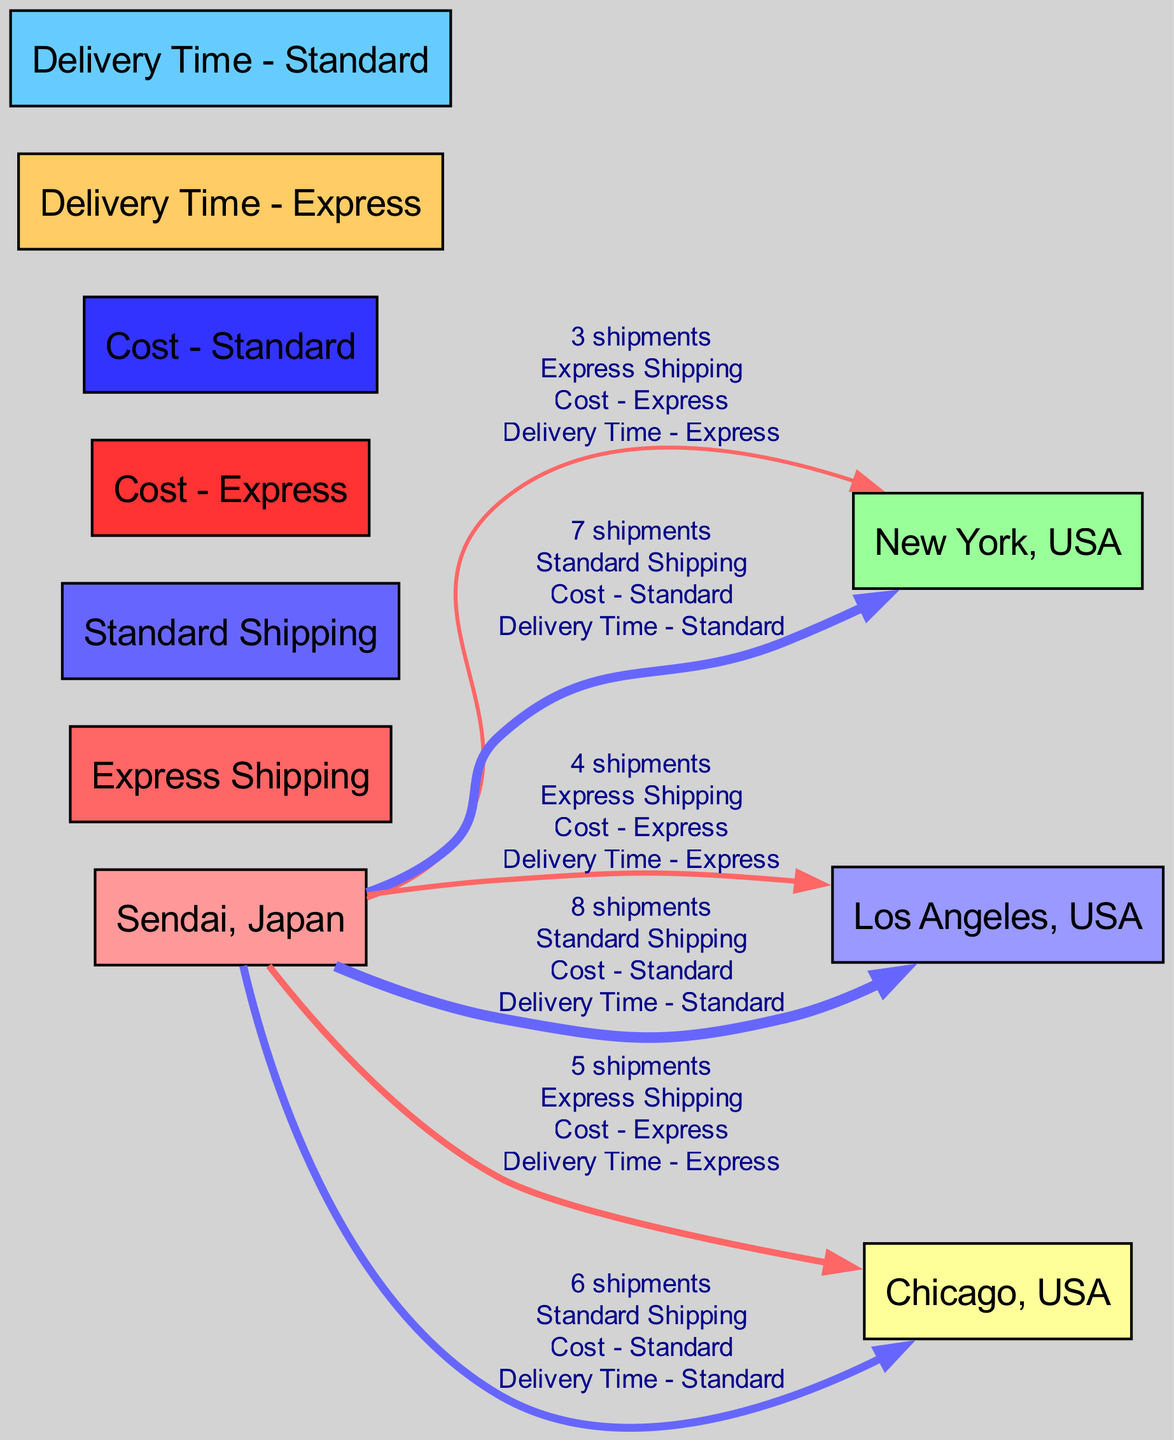What are the two shipping methods represented in the diagram? The diagram includes two distinct shipping methods: Express Shipping and Standard Shipping. These are shown as separate nodes in the diagram, indicating the different approaches to shipping goods from Sendai to the USA.
Answer: Express Shipping, Standard Shipping How many total shipments are sent to Los Angeles, USA? The total shipments to Los Angeles are the sum of the values from both shipping methods: 4 shipments via Express and 8 shipments via Standard Shipping, totaling 12 shipments. The labels on the edges to Los Angeles clarify the number of shipments for both methods.
Answer: 12 shipments What is the delivery time for shipments to Chicago using Standard Shipping? For Standard Shipping to Chicago, the delivery time is indicated in the edge connecting these two nodes. The value shows the delivery time as a distinct metric on that edge, which specifies the time of 6 days for this shipping method.
Answer: 6 Which city receives the most shipments using Express Shipping? Analyzing the connections from Sendai, the total value of shipments indicates the number for each city. For Express Shipping, Chicago receives the highest number at 5 shipments, compared to New York and Los Angeles which receive 3 and 4 respectively.
Answer: Chicago What is the cost associated with Express Shipping for shipments to New York, USA? The cost for shipments to New York using Express Shipping is represented as a label on the edge connecting these nodes. The diagram specifies the associated cost clearly, showing the cost as a quantitative value which is the same for all Express shipments, denoted simply.
Answer: Cost - Express How does the delivery time for Standard Shipping compare to Express Shipping for New York? For New York, the delivery time for Standard Shipping is 7 days while for Express Shipping it is only 3 days. Thus, Express Shipping considerably reduces the delivery time compared to Standard Shipping for this destination, as seen in the respective nodes.
Answer: Shorter What is the total value of shipments to New York using both methods? To find the total value to New York, add the shipments from both edges: 3 shipments from Express Shipping and 7 shipments from Standard Shipping. Therefore, the total for New York is 10 shipments overall, as each edge specifies its respective value.
Answer: 10 shipments Which shipping method is more cost-effective based on the diagram? The analysis of the diagram indicates the costs associated with both shipping methods. Since the standard method has lower costs compared to the Express method for no matter the destination, it can be inferred that Standard Shipping is the more cost-effective option.
Answer: Standard Shipping What is the main purpose of the Sankey Diagram in representing shipment data? The Sankey Diagram visually represents the flow of shipments from the origin (Sendai) to various destinations (cities in the USA) and allows for an easy comparison of the volume of shipments by method and destination alongside their associated costs and delivery times. This visualization provides a clear summary of multiple dimensions of the shipping data.
Answer: Visualize shipping data 